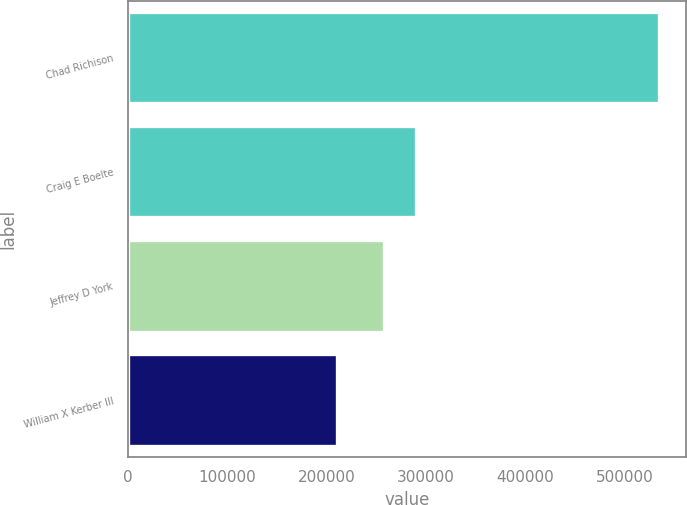Convert chart. <chart><loc_0><loc_0><loc_500><loc_500><bar_chart><fcel>Chad Richison<fcel>Craig E Boelte<fcel>Jeffrey D York<fcel>William X Kerber III<nl><fcel>534788<fcel>289929<fcel>257522<fcel>210722<nl></chart> 